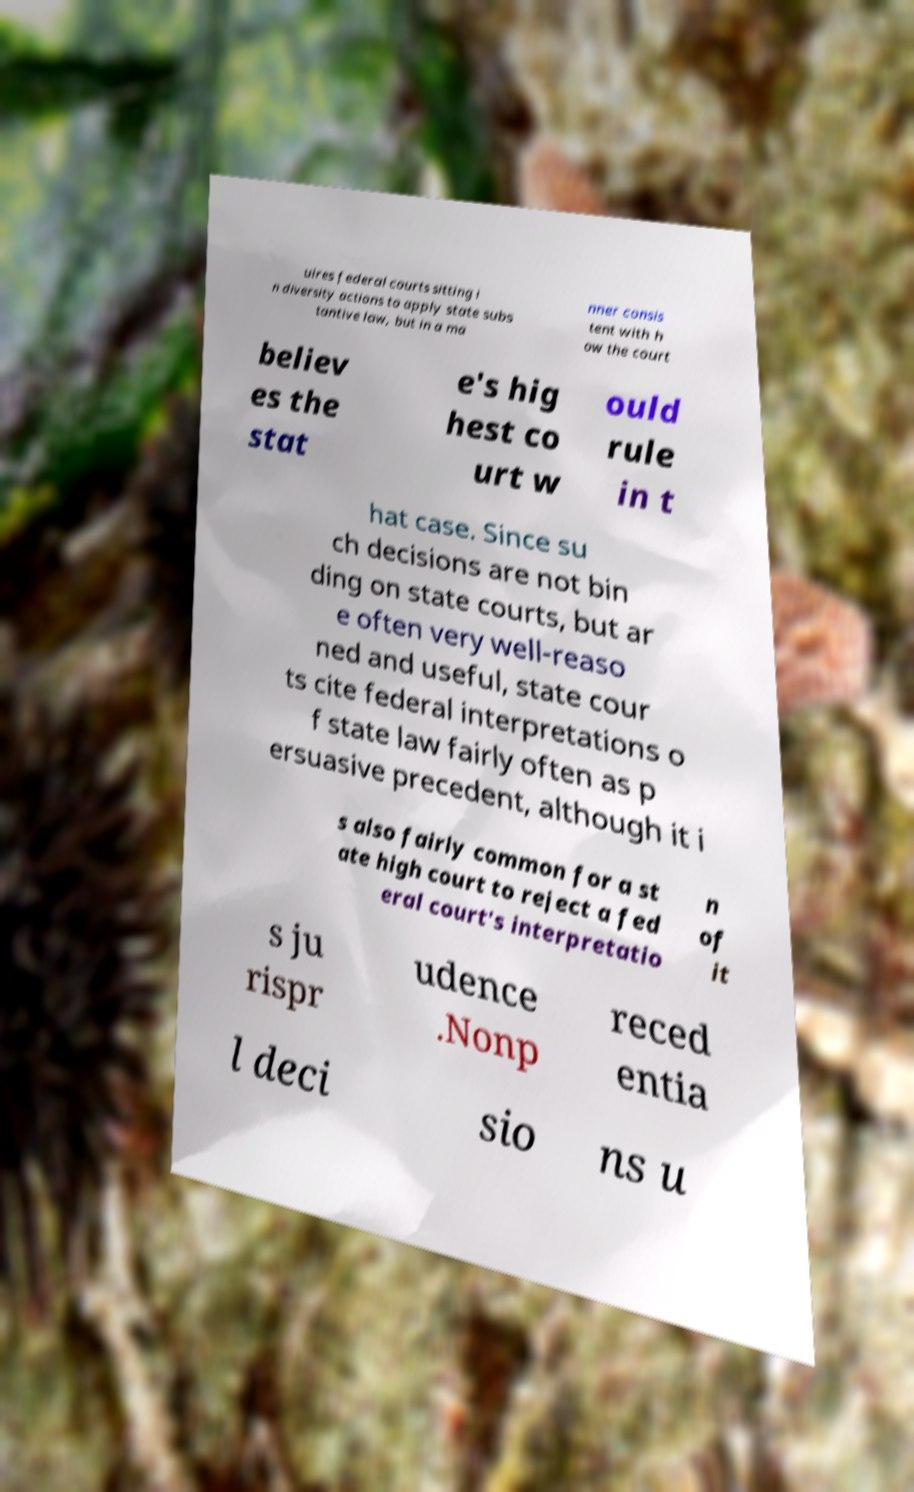For documentation purposes, I need the text within this image transcribed. Could you provide that? uires federal courts sitting i n diversity actions to apply state subs tantive law, but in a ma nner consis tent with h ow the court believ es the stat e's hig hest co urt w ould rule in t hat case. Since su ch decisions are not bin ding on state courts, but ar e often very well-reaso ned and useful, state cour ts cite federal interpretations o f state law fairly often as p ersuasive precedent, although it i s also fairly common for a st ate high court to reject a fed eral court's interpretatio n of it s ju rispr udence .Nonp reced entia l deci sio ns u 